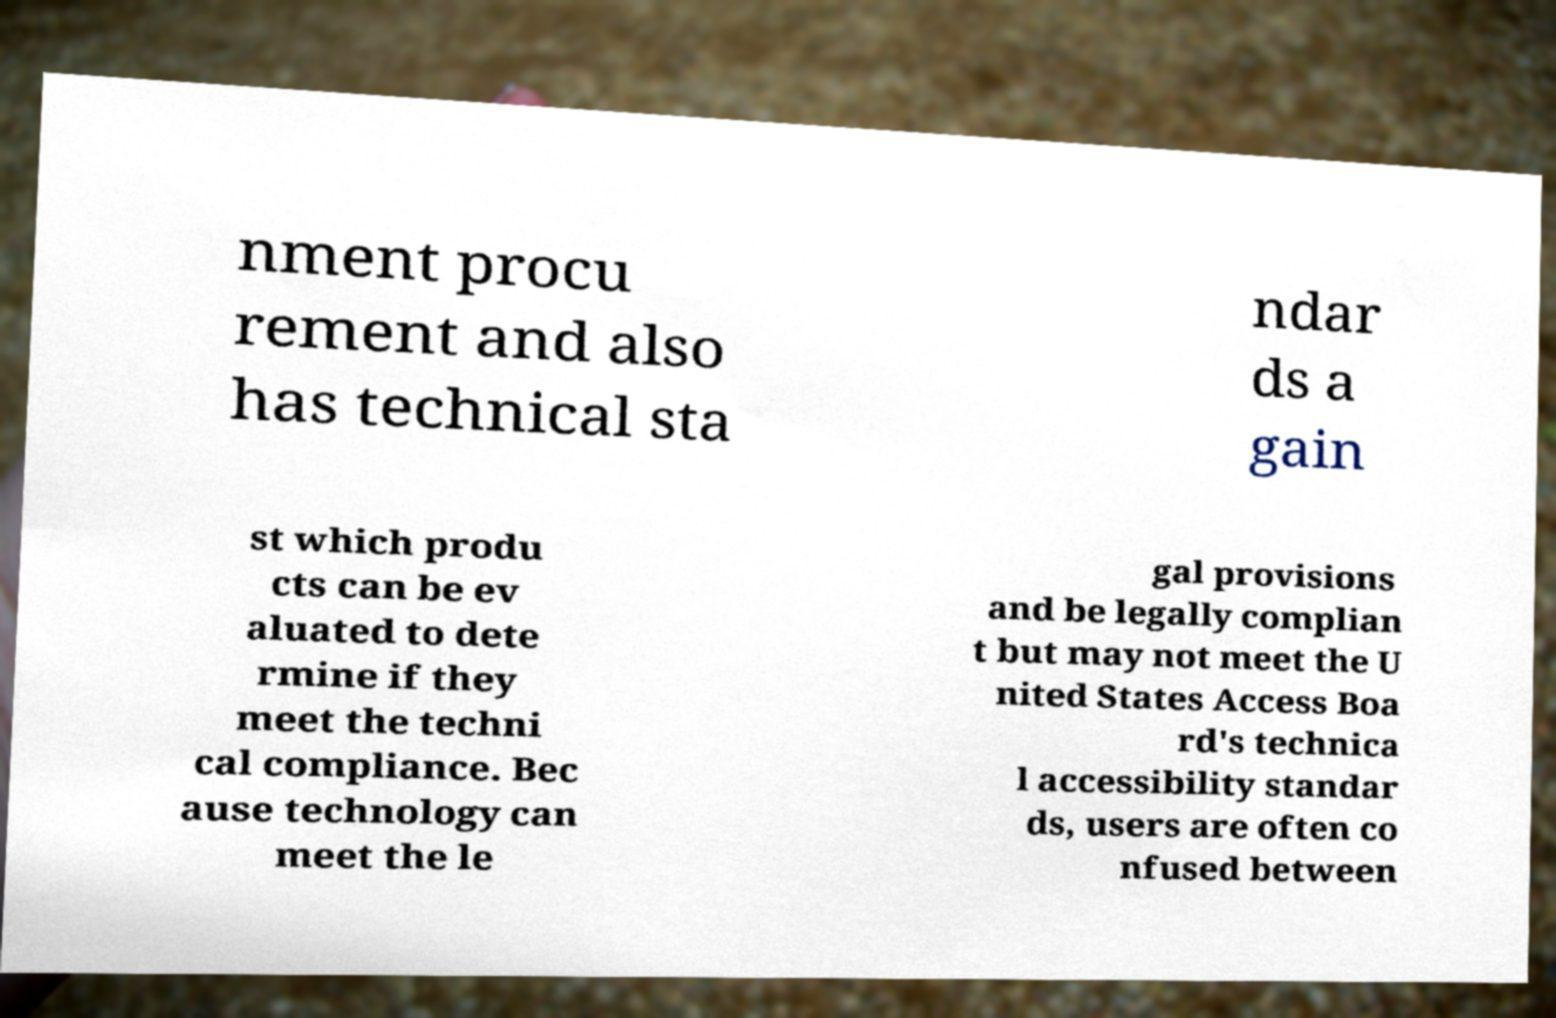There's text embedded in this image that I need extracted. Can you transcribe it verbatim? nment procu rement and also has technical sta ndar ds a gain st which produ cts can be ev aluated to dete rmine if they meet the techni cal compliance. Bec ause technology can meet the le gal provisions and be legally complian t but may not meet the U nited States Access Boa rd's technica l accessibility standar ds, users are often co nfused between 